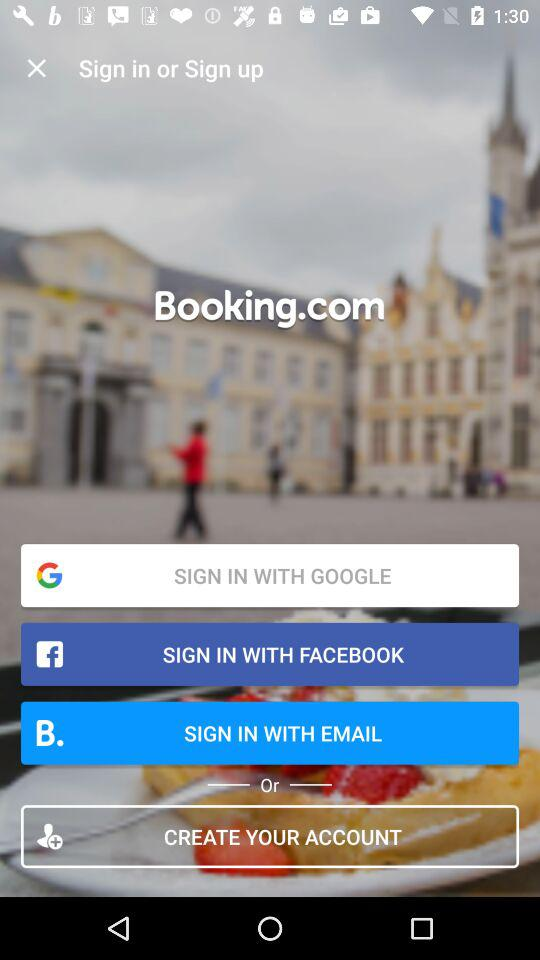What is the application name? The application name is "Booking.com". 